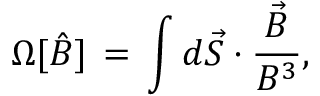Convert formula to latex. <formula><loc_0><loc_0><loc_500><loc_500>\Omega [ { \hat { B } } ] \, = \, \int d { \vec { S } } \cdot \frac { { \vec { B } } } { B ^ { 3 } } ,</formula> 